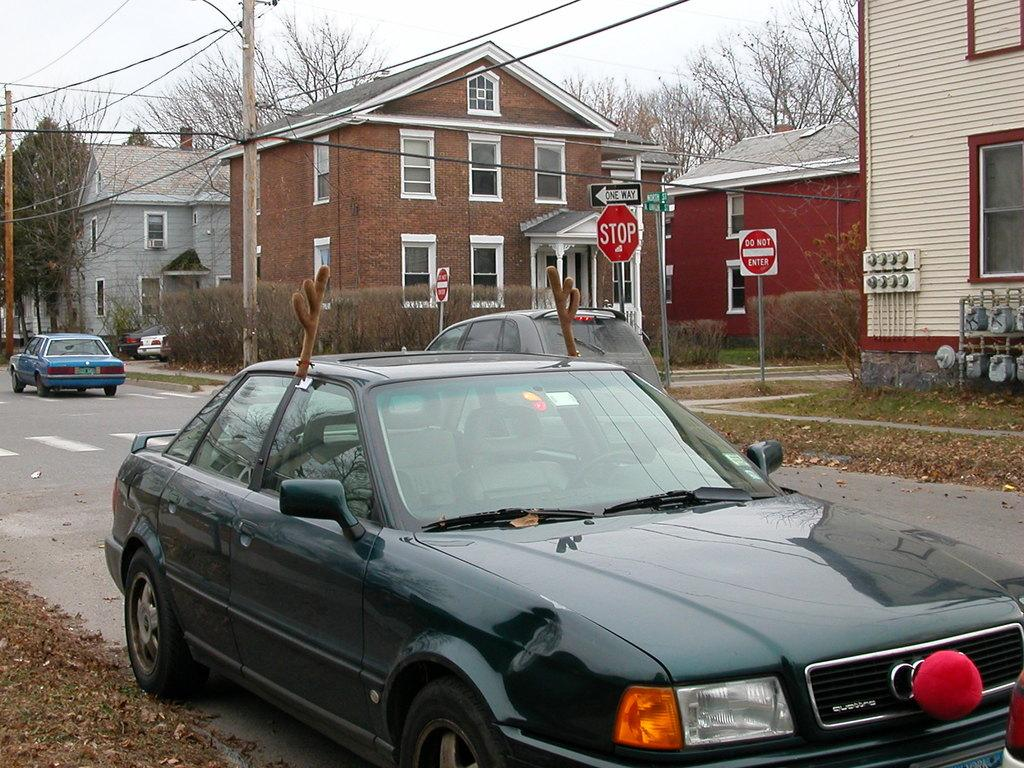What is happening on the road in the image? There are vehicles on the road in the image. What can be seen in the background of the image? There are buildings, boards, and poles with wires in the background of the image. What type of vegetation is present in the image? There are plants in the image. What is visible at the top of the image? The sky is visible at the top of the image. How many bikes are being used as an apparatus to catch the rat in the image? There are no bikes or rats present in the image. What type of apparatus is being used to catch the rat in the image? There is no apparatus or rat present in the image. 